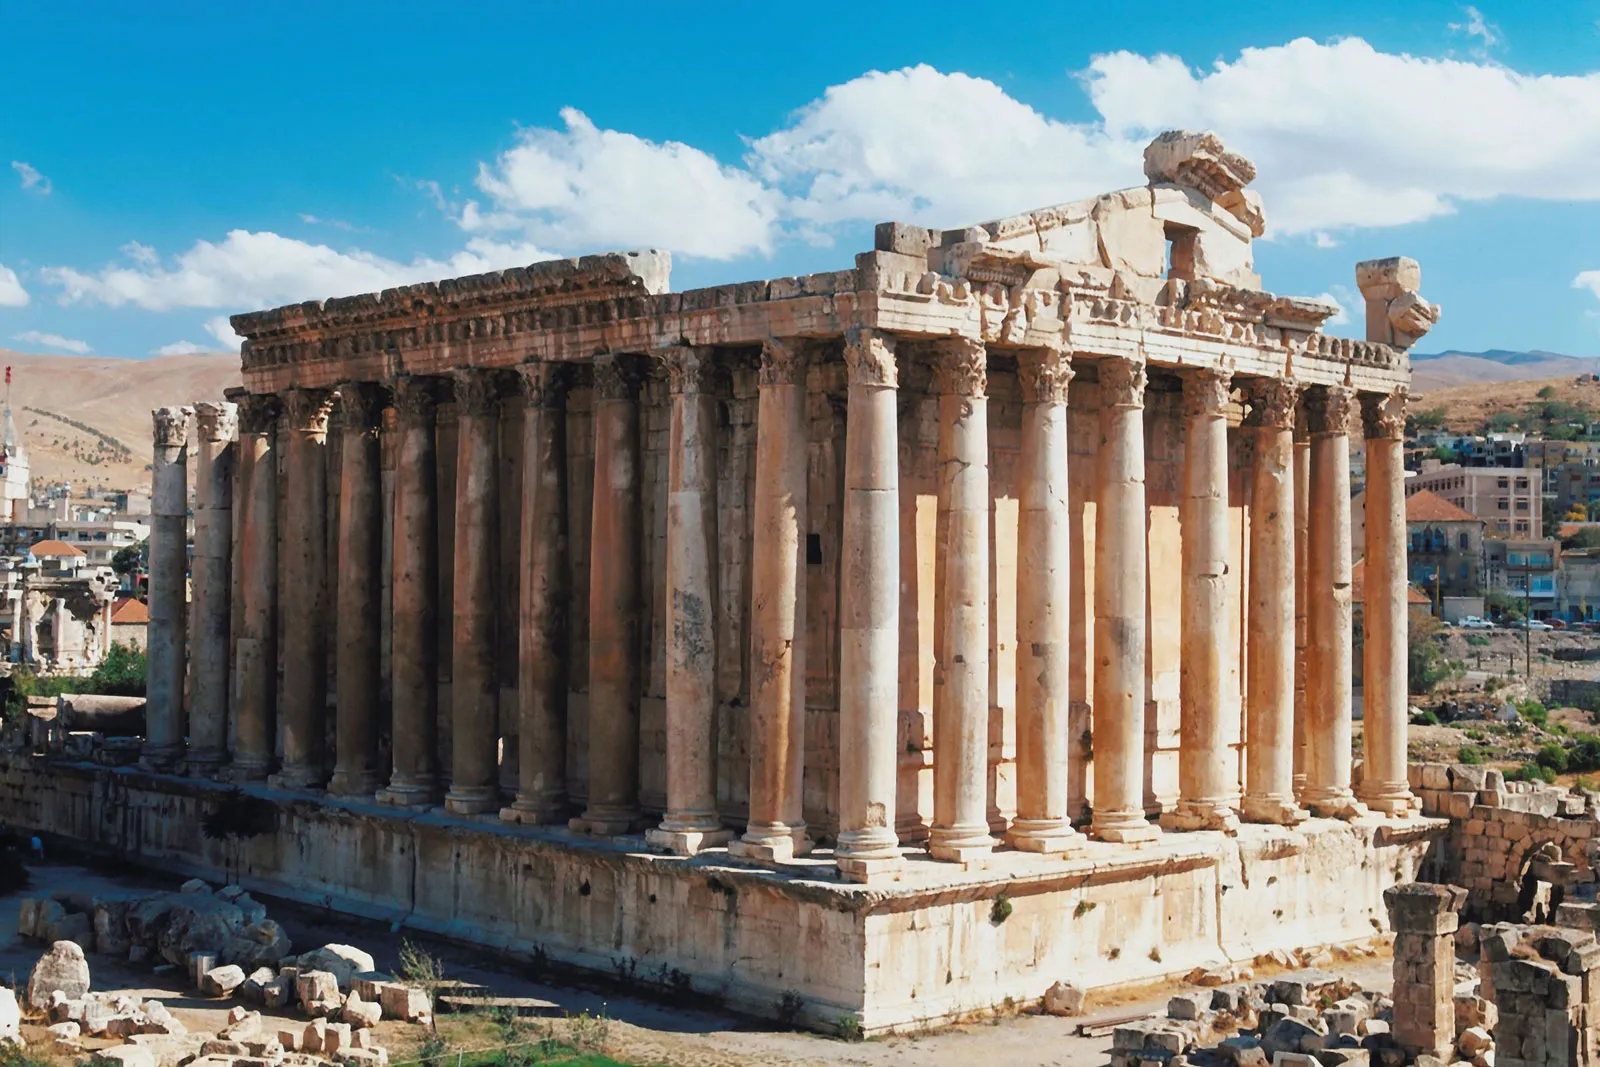What's the significance of the architectural elements seen in this temple? The architectural elements of the Temple of Jupiter reflect the grandeur of Roman architecture. The tall columns, reaching nearly 20 meters high, are iconic examples of Corinthian order, characterized by elaborate capitals decorated with acanthus leaves. The entablature above the columns would have been richly decorated, enhancing the temple’s majestic appearance. These elements not only contributed to the aesthetic and spiritual significance of the temple but also demonstrated the architectural advancements and artistic capabilities of the Roman Empire. 